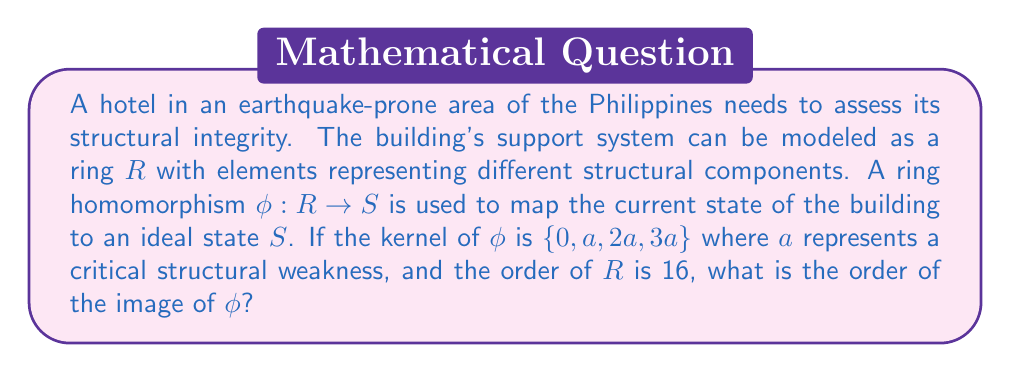Can you solve this math problem? To solve this problem, we'll use the First Isomorphism Theorem for rings and the properties of ring homomorphisms:

1) The First Isomorphism Theorem states that for a ring homomorphism $\phi: R \rightarrow S$, we have:

   $R/\text{ker}(\phi) \cong \text{Im}(\phi)$

2) This means that the order of $R$ divided by the order of $\text{ker}(\phi)$ equals the order of $\text{Im}(\phi)$:

   $|R| / |\text{ker}(\phi)| = |\text{Im}(\phi)|$

3) We're given that $|R| = 16$ and $\text{ker}(\phi) = \{0, a, 2a, 3a\}$

4) The order of $\text{ker}(\phi)$ is 4

5) Substituting these values into the equation from step 2:

   $16 / 4 = |\text{Im}(\phi)|$

6) Simplifying:

   $4 = |\text{Im}(\phi)|$

Therefore, the order of the image of $\phi$ is 4.
Answer: 4 